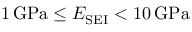<formula> <loc_0><loc_0><loc_500><loc_500>1 \, G P a \leq E _ { S E I } < 1 0 \, G P a</formula> 